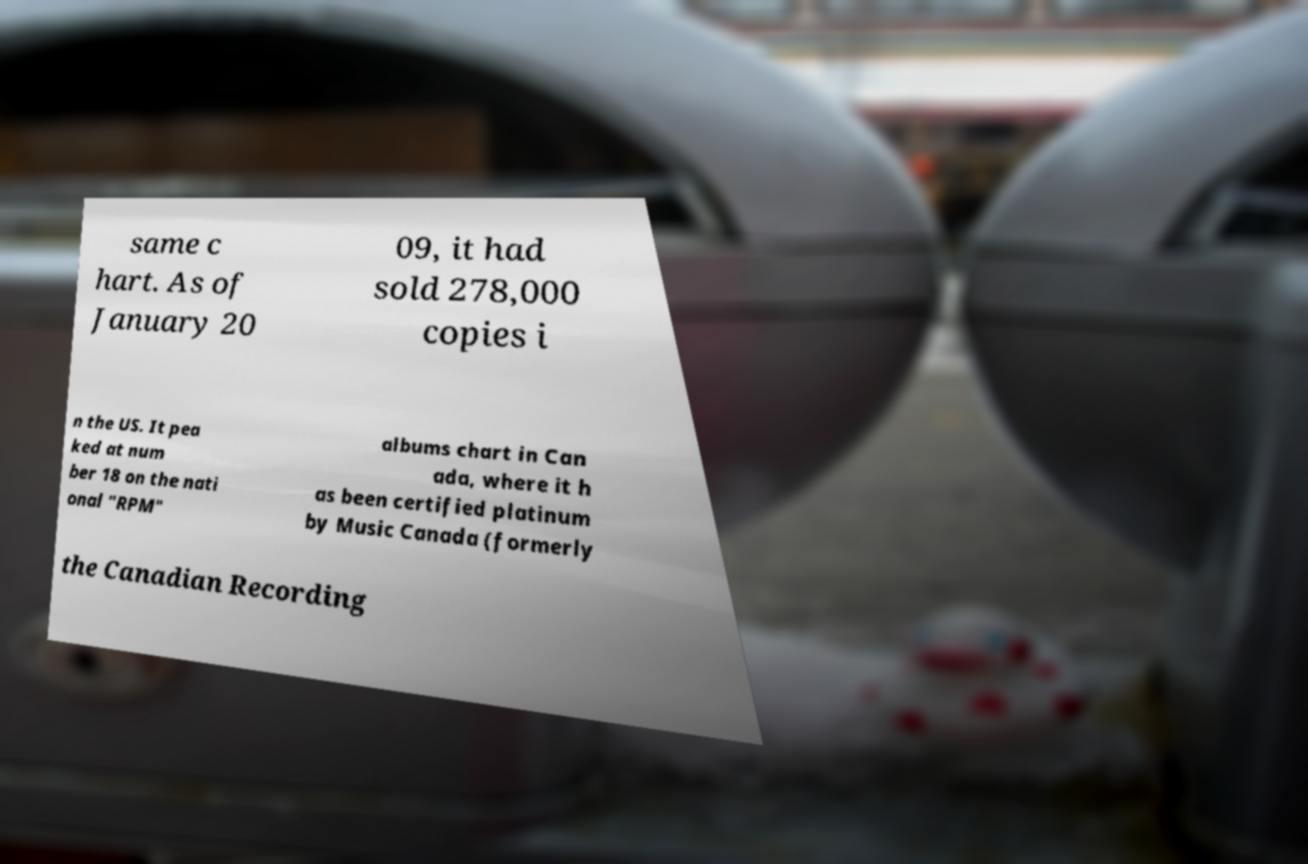Could you assist in decoding the text presented in this image and type it out clearly? same c hart. As of January 20 09, it had sold 278,000 copies i n the US. It pea ked at num ber 18 on the nati onal "RPM" albums chart in Can ada, where it h as been certified platinum by Music Canada (formerly the Canadian Recording 